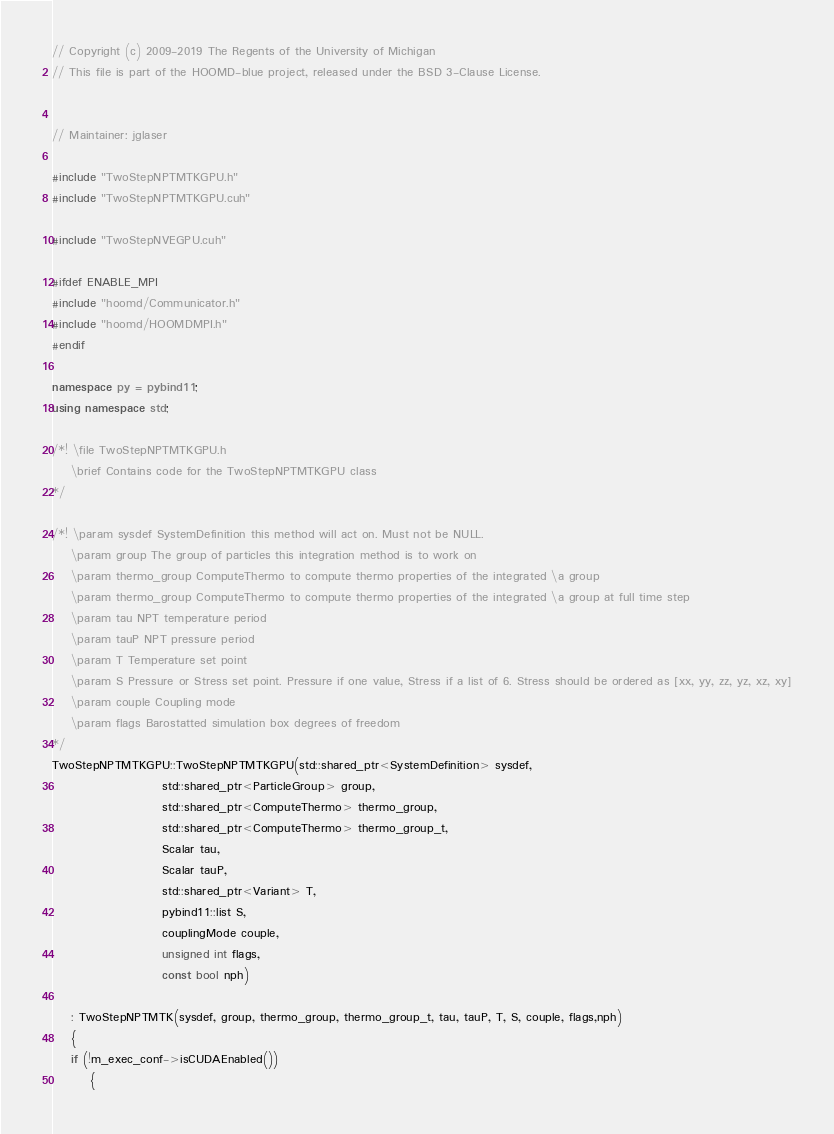<code> <loc_0><loc_0><loc_500><loc_500><_C++_>// Copyright (c) 2009-2019 The Regents of the University of Michigan
// This file is part of the HOOMD-blue project, released under the BSD 3-Clause License.


// Maintainer: jglaser

#include "TwoStepNPTMTKGPU.h"
#include "TwoStepNPTMTKGPU.cuh"

#include "TwoStepNVEGPU.cuh"

#ifdef ENABLE_MPI
#include "hoomd/Communicator.h"
#include "hoomd/HOOMDMPI.h"
#endif

namespace py = pybind11;
using namespace std;

/*! \file TwoStepNPTMTKGPU.h
    \brief Contains code for the TwoStepNPTMTKGPU class
*/

/*! \param sysdef SystemDefinition this method will act on. Must not be NULL.
    \param group The group of particles this integration method is to work on
    \param thermo_group ComputeThermo to compute thermo properties of the integrated \a group
    \param thermo_group ComputeThermo to compute thermo properties of the integrated \a group at full time step
    \param tau NPT temperature period
    \param tauP NPT pressure period
    \param T Temperature set point
    \param S Pressure or Stress set point. Pressure if one value, Stress if a list of 6. Stress should be ordered as [xx, yy, zz, yz, xz, xy]
    \param couple Coupling mode
    \param flags Barostatted simulation box degrees of freedom
*/
TwoStepNPTMTKGPU::TwoStepNPTMTKGPU(std::shared_ptr<SystemDefinition> sysdef,
                       std::shared_ptr<ParticleGroup> group,
                       std::shared_ptr<ComputeThermo> thermo_group,
                       std::shared_ptr<ComputeThermo> thermo_group_t,
                       Scalar tau,
                       Scalar tauP,
                       std::shared_ptr<Variant> T,
                       pybind11::list S,
                       couplingMode couple,
                       unsigned int flags,
                       const bool nph)

    : TwoStepNPTMTK(sysdef, group, thermo_group, thermo_group_t, tau, tauP, T, S, couple, flags,nph)
    {
    if (!m_exec_conf->isCUDAEnabled())
        {</code> 